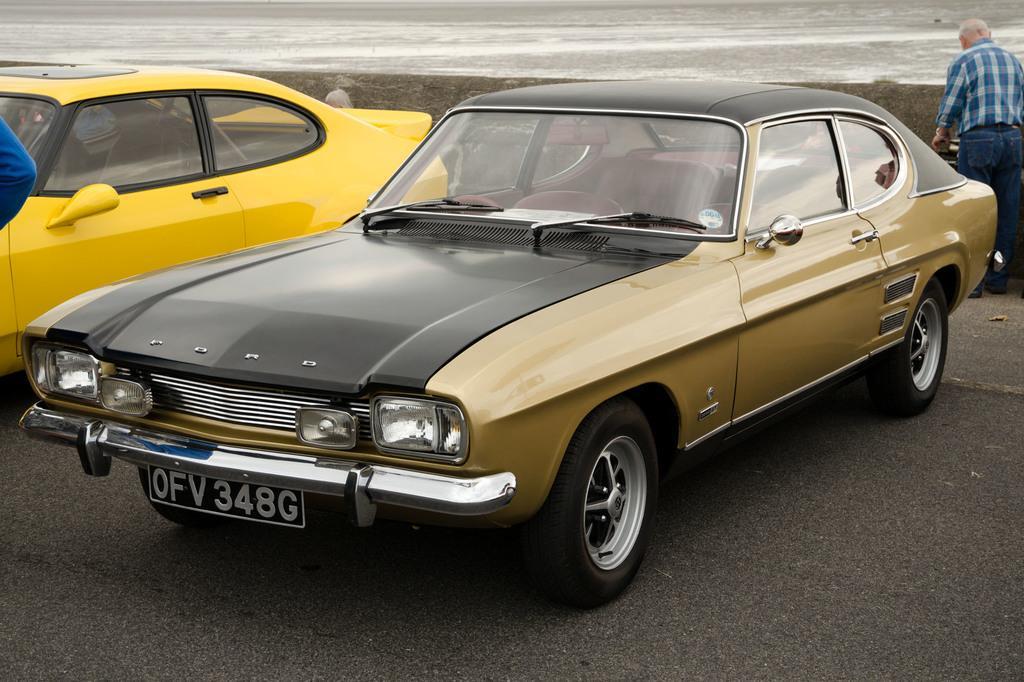Can you describe this image briefly? In this image we can see two vehicles parked on the ground. In the background, we can see two persons standing and the water. 